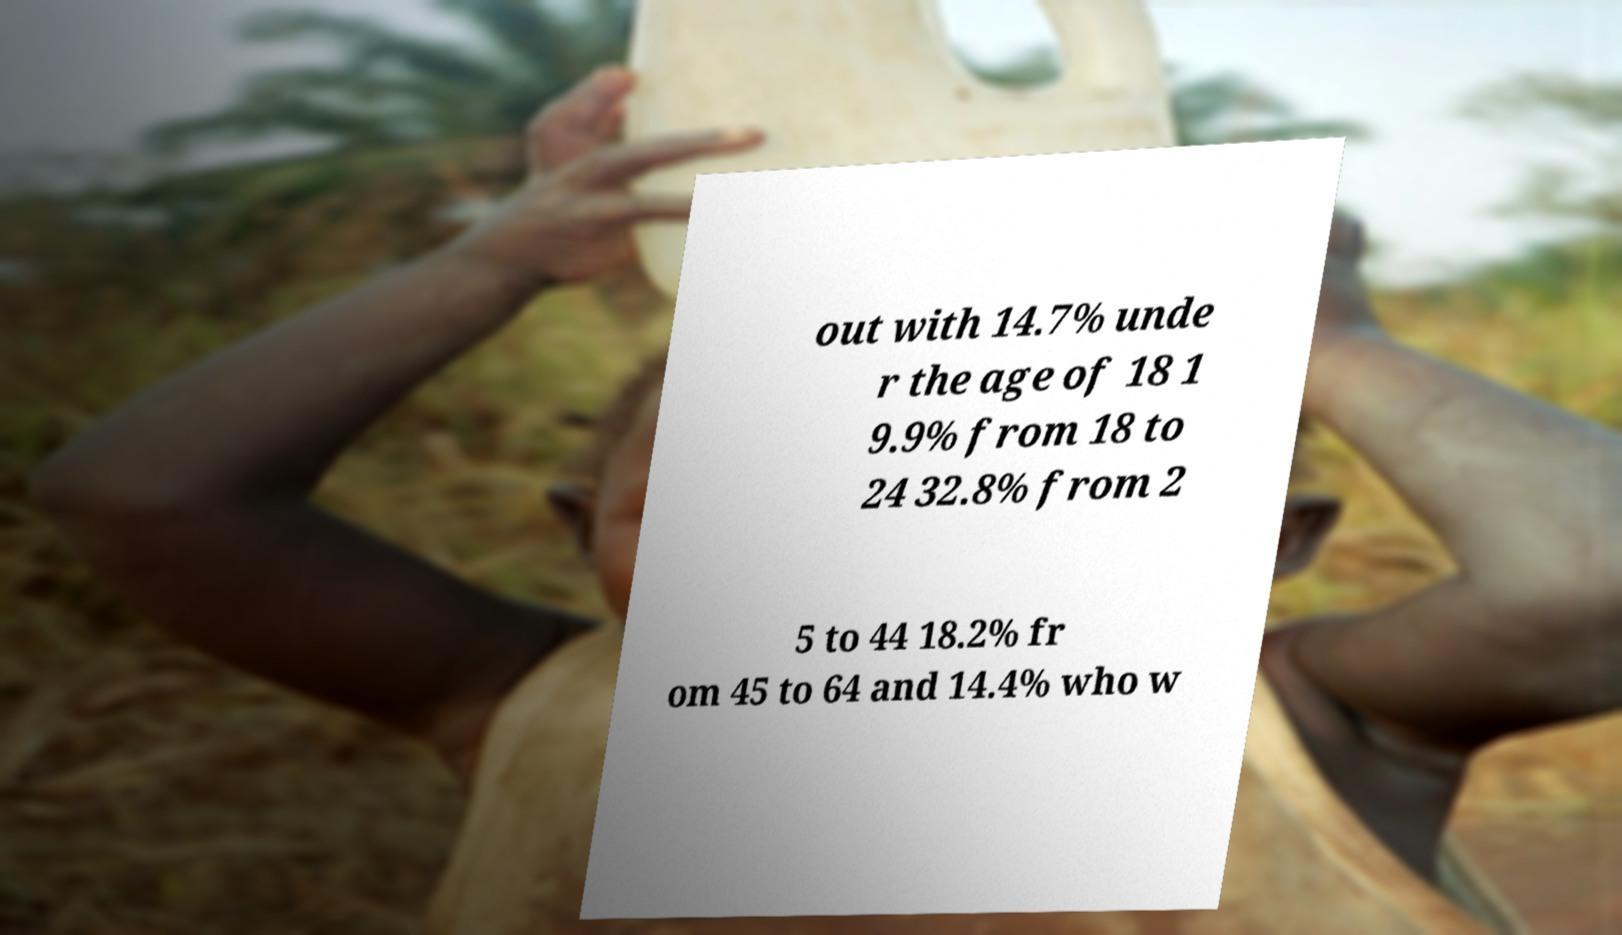Please read and relay the text visible in this image. What does it say? out with 14.7% unde r the age of 18 1 9.9% from 18 to 24 32.8% from 2 5 to 44 18.2% fr om 45 to 64 and 14.4% who w 